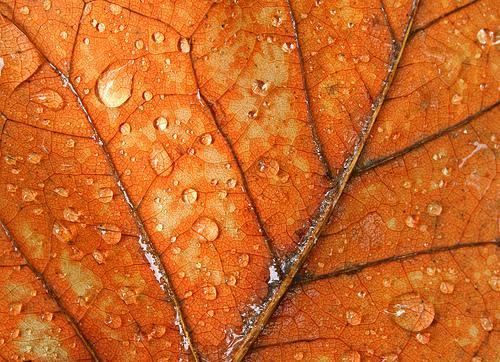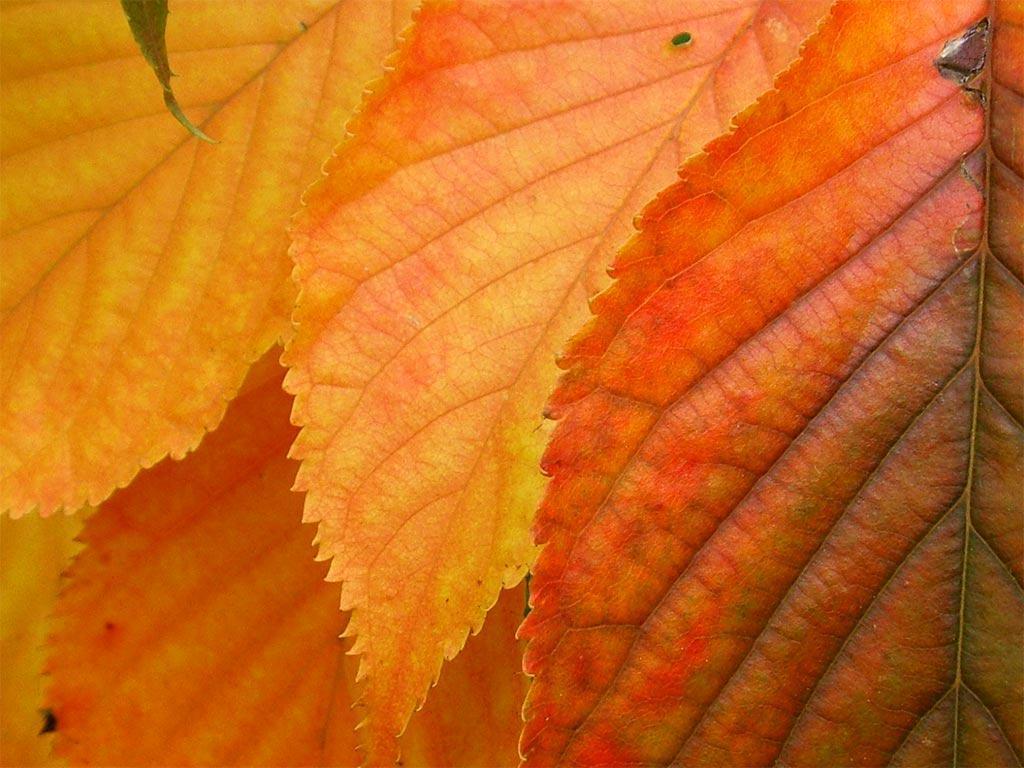The first image is the image on the left, the second image is the image on the right. Considering the images on both sides, is "The right image shows a bunch of autumn leaves shaped like maple leaves." valid? Answer yes or no. No. 